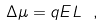<formula> <loc_0><loc_0><loc_500><loc_500>\Delta \mu = q E L \ ,</formula> 